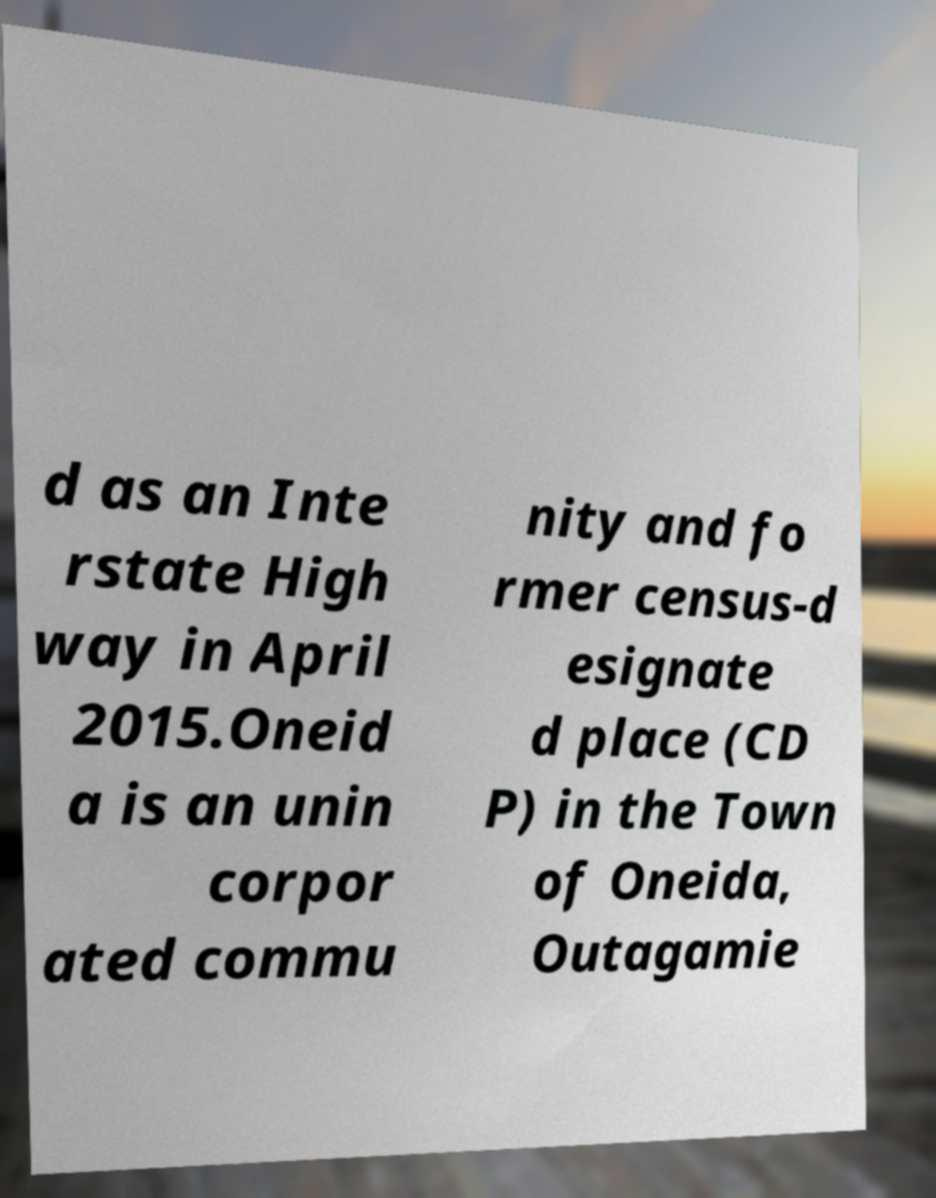Can you accurately transcribe the text from the provided image for me? d as an Inte rstate High way in April 2015.Oneid a is an unin corpor ated commu nity and fo rmer census-d esignate d place (CD P) in the Town of Oneida, Outagamie 